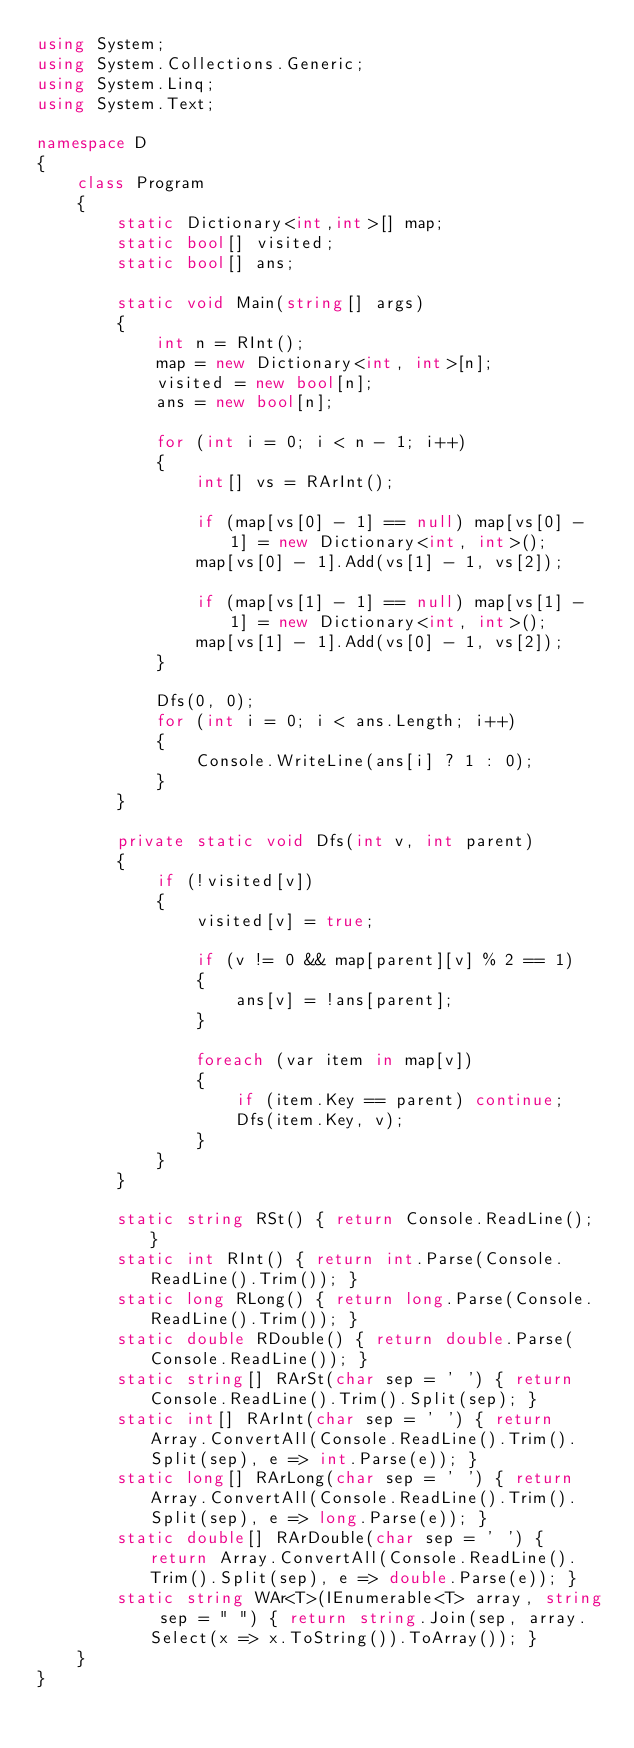Convert code to text. <code><loc_0><loc_0><loc_500><loc_500><_C#_>using System;
using System.Collections.Generic;
using System.Linq;
using System.Text;

namespace D
{
    class Program
    {
        static Dictionary<int,int>[] map;
        static bool[] visited;
        static bool[] ans;

        static void Main(string[] args)
        {
            int n = RInt();
            map = new Dictionary<int, int>[n];
            visited = new bool[n];
            ans = new bool[n];

            for (int i = 0; i < n - 1; i++)
            {
                int[] vs = RArInt();

                if (map[vs[0] - 1] == null) map[vs[0] - 1] = new Dictionary<int, int>();
                map[vs[0] - 1].Add(vs[1] - 1, vs[2]);

                if (map[vs[1] - 1] == null) map[vs[1] - 1] = new Dictionary<int, int>();
                map[vs[1] - 1].Add(vs[0] - 1, vs[2]);
            }

            Dfs(0, 0);
            for (int i = 0; i < ans.Length; i++)
            {
                Console.WriteLine(ans[i] ? 1 : 0);
            }
        }

        private static void Dfs(int v, int parent)
        {
            if (!visited[v])
            {
                visited[v] = true;

                if (v != 0 && map[parent][v] % 2 == 1)
                {
                    ans[v] = !ans[parent];
                }

                foreach (var item in map[v])
                {
                    if (item.Key == parent) continue;
                    Dfs(item.Key, v);
                }
            }
        }

        static string RSt() { return Console.ReadLine(); }
        static int RInt() { return int.Parse(Console.ReadLine().Trim()); }
        static long RLong() { return long.Parse(Console.ReadLine().Trim()); }
        static double RDouble() { return double.Parse(Console.ReadLine()); }
        static string[] RArSt(char sep = ' ') { return Console.ReadLine().Trim().Split(sep); }
        static int[] RArInt(char sep = ' ') { return Array.ConvertAll(Console.ReadLine().Trim().Split(sep), e => int.Parse(e)); }
        static long[] RArLong(char sep = ' ') { return Array.ConvertAll(Console.ReadLine().Trim().Split(sep), e => long.Parse(e)); }
        static double[] RArDouble(char sep = ' ') { return Array.ConvertAll(Console.ReadLine().Trim().Split(sep), e => double.Parse(e)); }
        static string WAr<T>(IEnumerable<T> array, string sep = " ") { return string.Join(sep, array.Select(x => x.ToString()).ToArray()); }
    }
}
</code> 